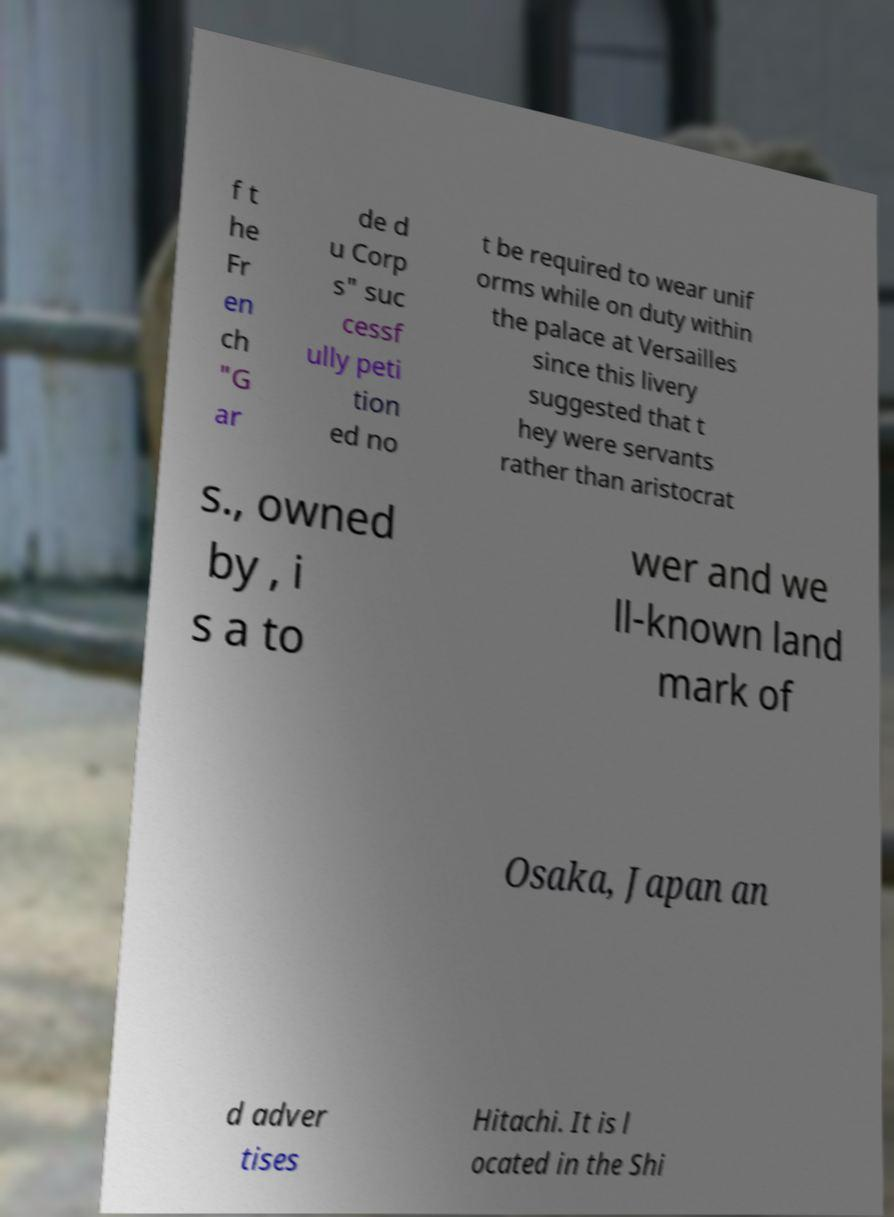Could you assist in decoding the text presented in this image and type it out clearly? f t he Fr en ch "G ar de d u Corp s" suc cessf ully peti tion ed no t be required to wear unif orms while on duty within the palace at Versailles since this livery suggested that t hey were servants rather than aristocrat s., owned by , i s a to wer and we ll-known land mark of Osaka, Japan an d adver tises Hitachi. It is l ocated in the Shi 